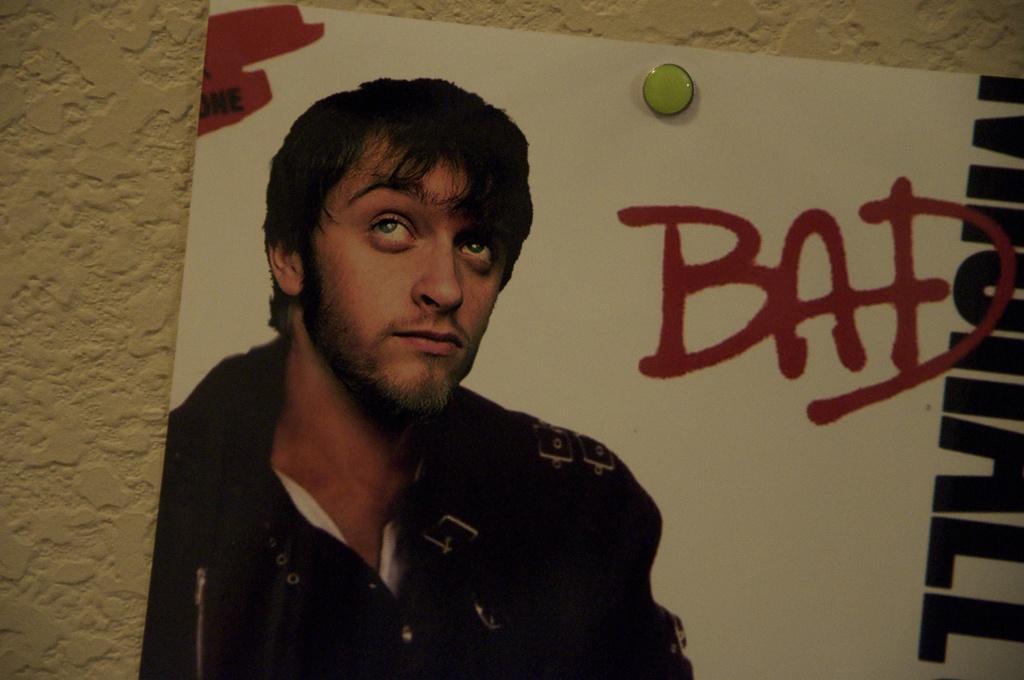Could you give a brief overview of what you see in this image? There is one poster attached on the wall as we can see in the middle of this image. We can see there is a picture of a person on the poster. There is some text written on the right side of this image. 